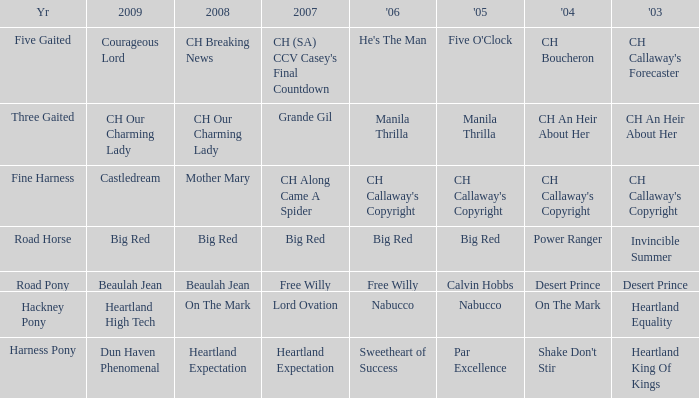What year is the 2004 shake don't stir? Harness Pony. 